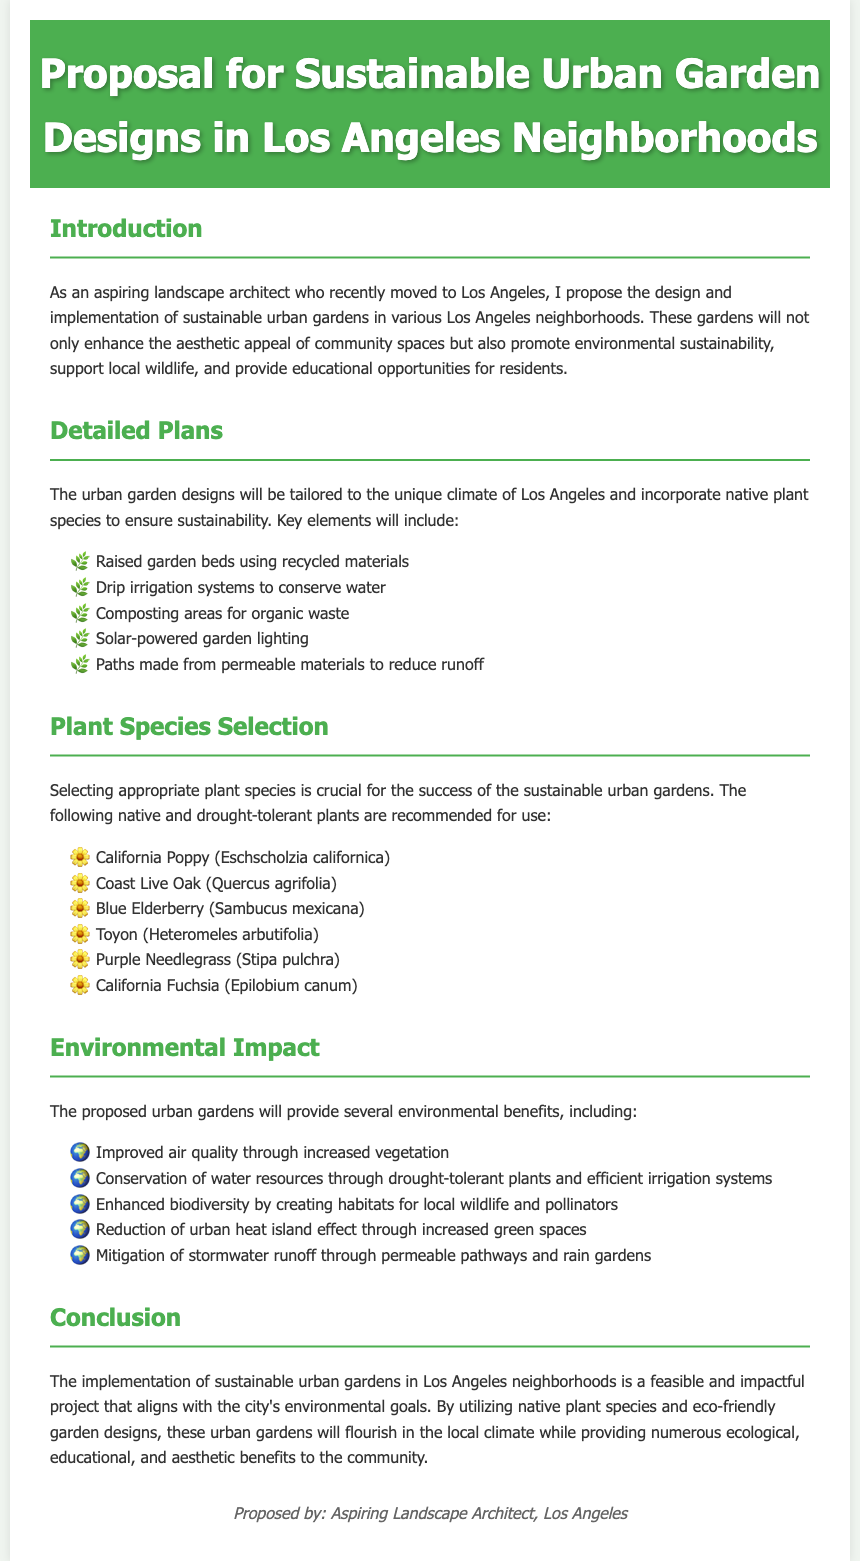what is the title of the proposal? The title is provided in the header section of the document.
Answer: Proposal for Sustainable Urban Garden Designs in Los Angeles Neighborhoods how many native plant species are recommended? The document lists specific plant species in the Plant Species Selection section.
Answer: Six what type of irrigation system is proposed? The type of irrigation system is mentioned in the Detailed Plans section.
Answer: Drip irrigation systems what environmental impact is expected from the gardens? The expected environmental impacts are listed in the Environmental Impact section.
Answer: Improved air quality which plant species is known as California Poppy? The common name of the plant is mentioned in the Plant Species Selection section.
Answer: Eschscholzia californica who proposed the document? The proposer is identified at the end of the document in the footer section.
Answer: Aspiring Landscape Architect what is the main purpose of the sustainable urban gardens? The main purpose is outlined in the Introduction section.
Answer: Promote environmental sustainability how will stormwater runoff be mitigated? The method of mitigation is described in the Environmental Impact section.
Answer: Through permeable pathways and rain gardens 